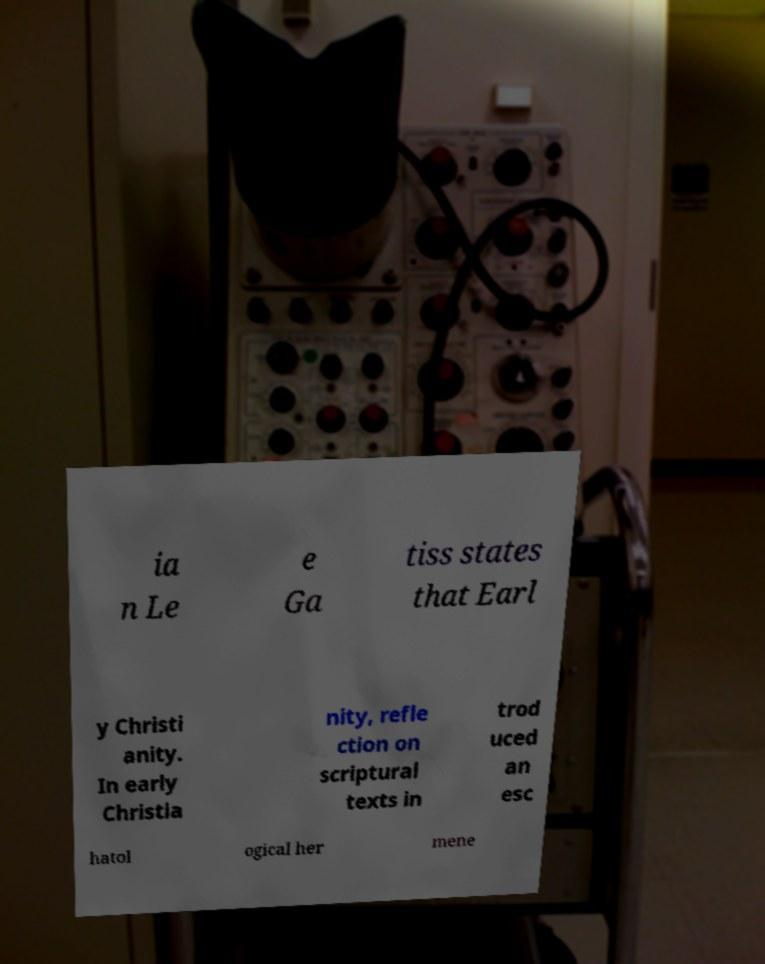Could you assist in decoding the text presented in this image and type it out clearly? ia n Le e Ga tiss states that Earl y Christi anity. In early Christia nity, refle ction on scriptural texts in trod uced an esc hatol ogical her mene 